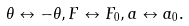Convert formula to latex. <formula><loc_0><loc_0><loc_500><loc_500>\theta \leftrightarrow - \theta , F \leftrightarrow F _ { 0 } , a \leftrightarrow a _ { 0 } .</formula> 